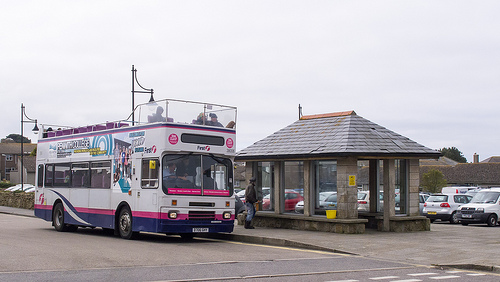What is on the pavement? A bus is on the pavement. 